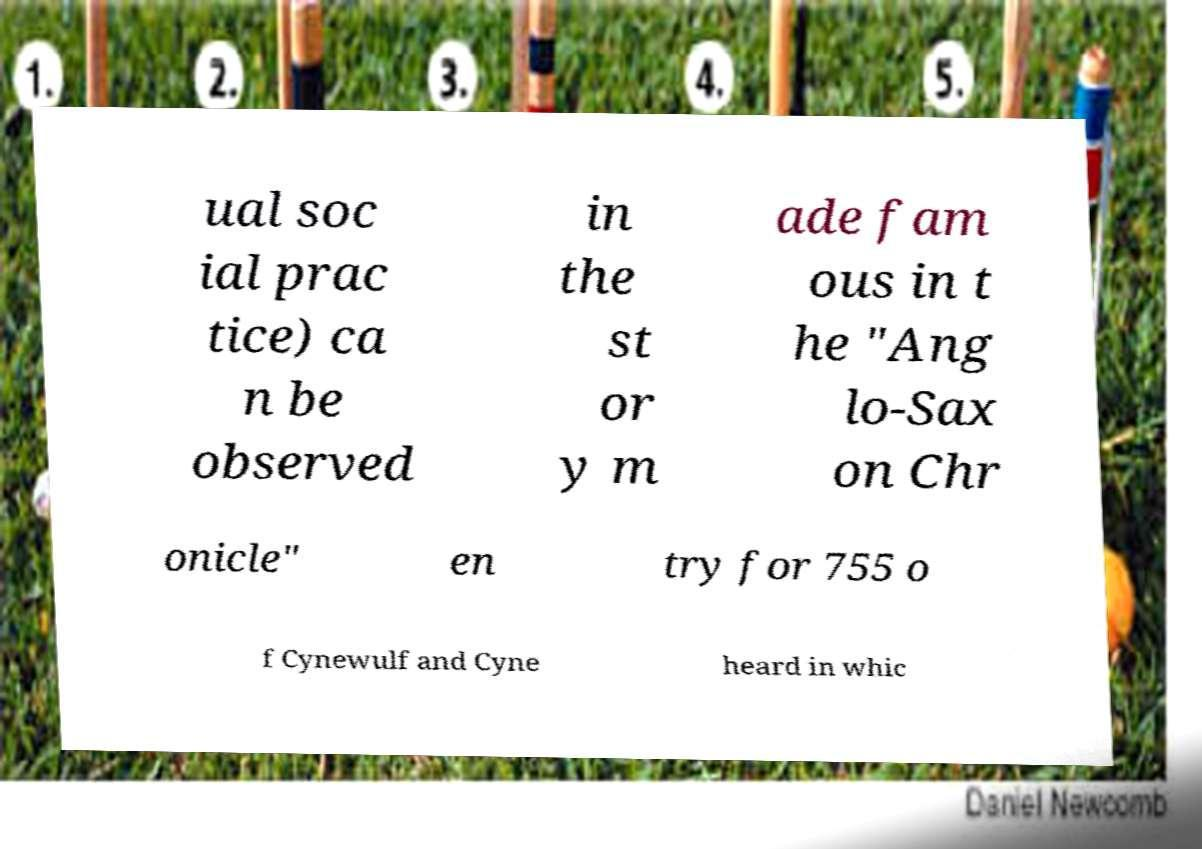Please read and relay the text visible in this image. What does it say? ual soc ial prac tice) ca n be observed in the st or y m ade fam ous in t he "Ang lo-Sax on Chr onicle" en try for 755 o f Cynewulf and Cyne heard in whic 